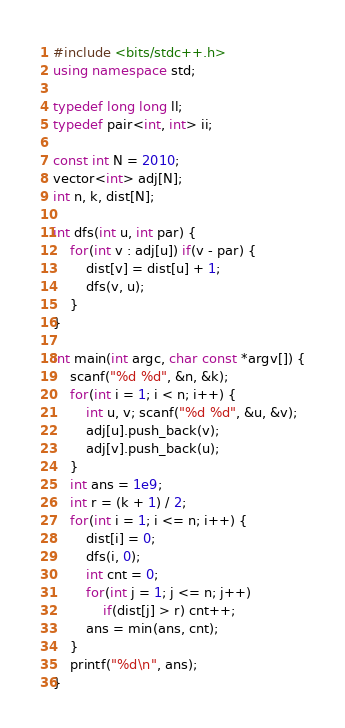<code> <loc_0><loc_0><loc_500><loc_500><_C++_>#include <bits/stdc++.h>
using namespace std;

typedef long long ll;
typedef pair<int, int> ii; 

const int N = 2010; 
vector<int> adj[N];
int n, k, dist[N]; 

int dfs(int u, int par) {
    for(int v : adj[u]) if(v - par) {
        dist[v] = dist[u] + 1; 
        dfs(v, u); 
    }
}

int main(int argc, char const *argv[]) {
    scanf("%d %d", &n, &k); 
    for(int i = 1; i < n; i++) {
        int u, v; scanf("%d %d", &u, &v); 
        adj[u].push_back(v);
        adj[v].push_back(u); 
    }
    int ans = 1e9; 
    int r = (k + 1) / 2; 
    for(int i = 1; i <= n; i++) {
        dist[i] = 0; 
        dfs(i, 0); 
        int cnt = 0; 
        for(int j = 1; j <= n; j++) 
            if(dist[j] > r) cnt++;
        ans = min(ans, cnt); 
    }
    printf("%d\n", ans); 
}
</code> 